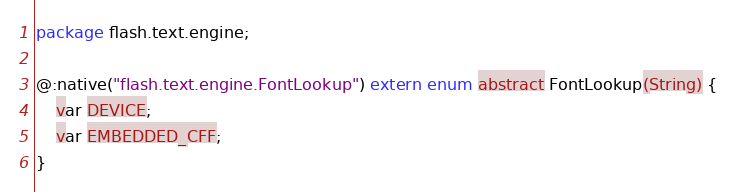<code> <loc_0><loc_0><loc_500><loc_500><_Haxe_>package flash.text.engine;

@:native("flash.text.engine.FontLookup") extern enum abstract FontLookup(String) {
	var DEVICE;
	var EMBEDDED_CFF;
}
</code> 